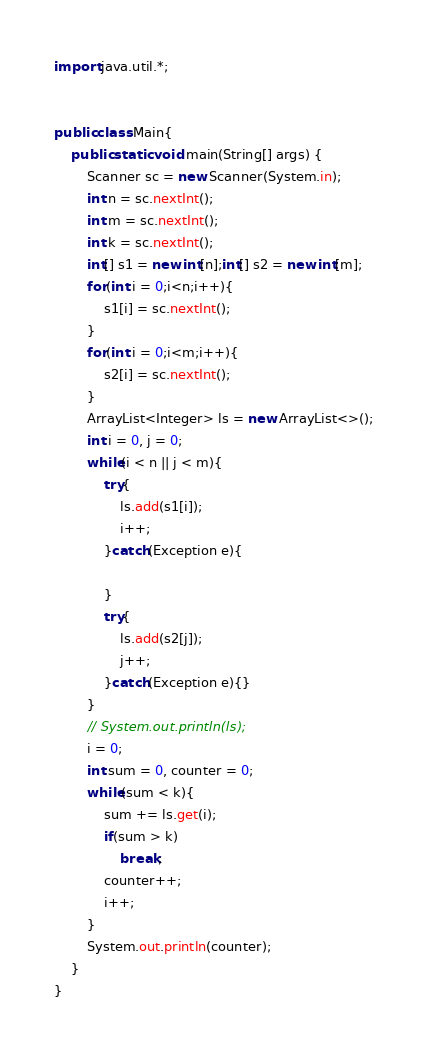Convert code to text. <code><loc_0><loc_0><loc_500><loc_500><_Java_>
import java.util.*;


public class Main{
    public static void main(String[] args) {
        Scanner sc = new Scanner(System.in);
        int n = sc.nextInt();
        int m = sc.nextInt();
        int k = sc.nextInt();
        int[] s1 = new int[n];int[] s2 = new int[m];
        for(int i = 0;i<n;i++){
            s1[i] = sc.nextInt();
        }
        for(int i = 0;i<m;i++){
            s2[i] = sc.nextInt();
        }
        ArrayList<Integer> ls = new ArrayList<>();
        int i = 0, j = 0;
        while(i < n || j < m){
            try{
                ls.add(s1[i]);
                i++;
            }catch(Exception e){

            }
            try{
                ls.add(s2[j]);
                j++;
            }catch(Exception e){}
        }
        // System.out.println(ls);
        i = 0;
        int sum = 0, counter = 0;
        while(sum < k){
            sum += ls.get(i);
            if(sum > k)
                break;
            counter++;
            i++;
        }
        System.out.println(counter);
    }
}</code> 